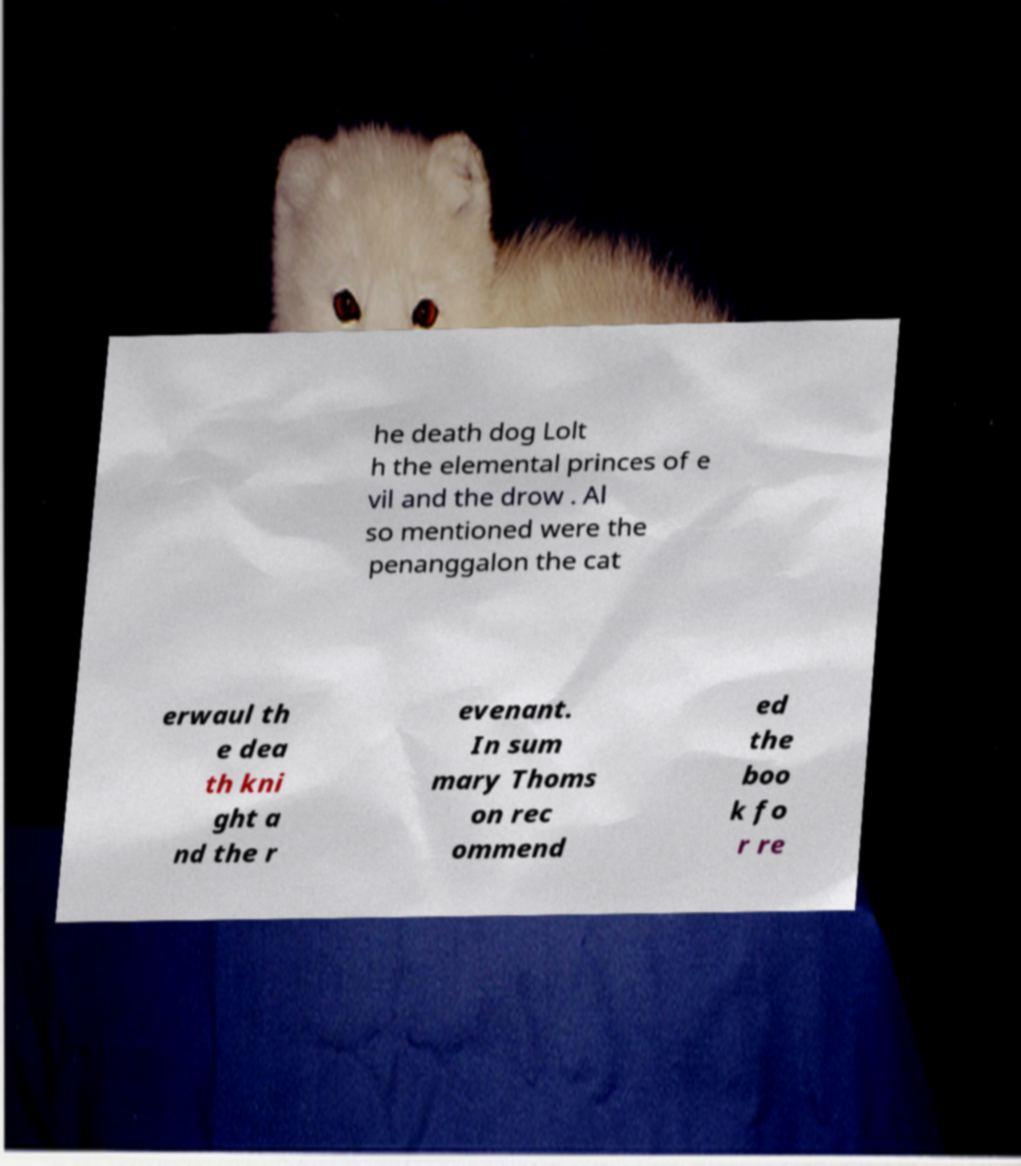Can you read and provide the text displayed in the image?This photo seems to have some interesting text. Can you extract and type it out for me? he death dog Lolt h the elemental princes of e vil and the drow . Al so mentioned were the penanggalon the cat erwaul th e dea th kni ght a nd the r evenant. In sum mary Thoms on rec ommend ed the boo k fo r re 